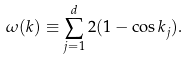<formula> <loc_0><loc_0><loc_500><loc_500>\omega ( { k } ) \equiv \sum _ { j = 1 } ^ { d } 2 ( 1 - \cos k _ { j } ) .</formula> 